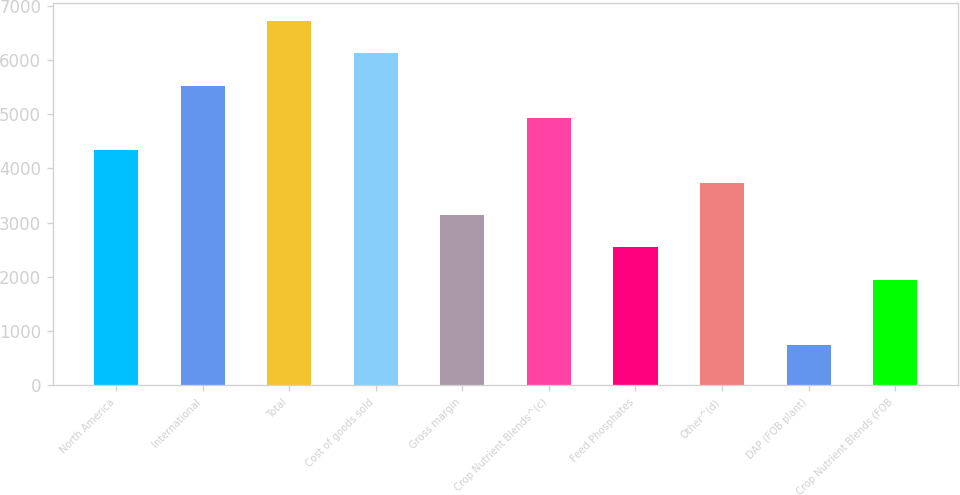Convert chart. <chart><loc_0><loc_0><loc_500><loc_500><bar_chart><fcel>North America<fcel>International<fcel>Total<fcel>Cost of goods sold<fcel>Gross margin<fcel>Crop Nutrient Blends^(c)<fcel>Feed Phosphates<fcel>Other^(d)<fcel>DAP (FOB plant)<fcel>Crop Nutrient Blends (FOB<nl><fcel>4332.22<fcel>5525.14<fcel>6718.06<fcel>6121.6<fcel>3139.3<fcel>4928.68<fcel>2542.84<fcel>3735.76<fcel>753.46<fcel>1946.38<nl></chart> 